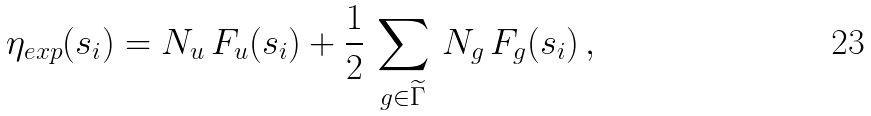<formula> <loc_0><loc_0><loc_500><loc_500>\eta _ { e x p } ( s _ { i } ) = N _ { u } \, F _ { u } ( s _ { i } ) + \frac { 1 } { 2 } \, \sum _ { g \in \widetilde { \Gamma } } \, N _ { g } \, F _ { g } ( s _ { i } ) \, ,</formula> 